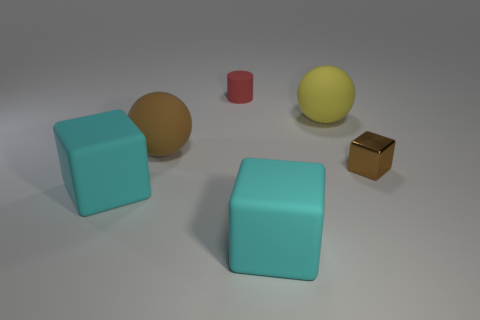Are there any other things that are the same shape as the tiny red object?
Offer a very short reply. No. Are there an equal number of large rubber balls that are in front of the shiny object and small things that are in front of the large yellow ball?
Offer a terse response. No. There is a object that is both behind the big brown sphere and in front of the small red matte cylinder; what is its color?
Your answer should be very brief. Yellow. Is the number of things in front of the red matte cylinder greater than the number of cyan rubber blocks that are on the right side of the tiny brown shiny block?
Give a very brief answer. Yes. Does the brown thing that is on the left side of the brown metal thing have the same size as the yellow matte object?
Your answer should be compact. Yes. How many balls are to the right of the cyan rubber thing on the right side of the cyan rubber block to the left of the cylinder?
Offer a very short reply. 1. There is a rubber object that is left of the tiny red rubber object and in front of the brown cube; what size is it?
Your answer should be compact. Large. How many other things are there of the same shape as the yellow thing?
Ensure brevity in your answer.  1. There is a yellow matte sphere; how many blocks are on the left side of it?
Your answer should be very brief. 2. Are there fewer small red things that are on the right side of the red rubber object than cyan matte objects behind the large brown matte sphere?
Keep it short and to the point. No. 